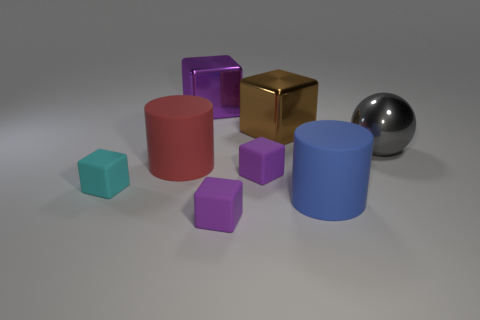What size is the brown shiny thing that is the same shape as the large purple metallic thing?
Make the answer very short. Large. What number of brown blocks are in front of the large gray thing?
Provide a short and direct response. 0. Is there any other thing that has the same size as the gray metallic ball?
Offer a terse response. Yes. What is the color of the other large thing that is the same material as the red thing?
Ensure brevity in your answer.  Blue. Is the brown thing the same shape as the big purple thing?
Provide a succinct answer. Yes. How many blocks are on the left side of the big red matte cylinder and behind the gray shiny object?
Make the answer very short. 0. How many metallic objects are either large brown objects or big blue cylinders?
Your response must be concise. 1. What is the size of the matte cylinder on the left side of the purple object that is behind the large shiny sphere?
Ensure brevity in your answer.  Large. Is there a matte block that is behind the tiny purple matte thing in front of the big matte cylinder that is in front of the cyan cube?
Your answer should be very brief. Yes. Do the tiny purple object that is in front of the large blue matte object and the cylinder that is behind the small cyan block have the same material?
Your answer should be compact. Yes. 